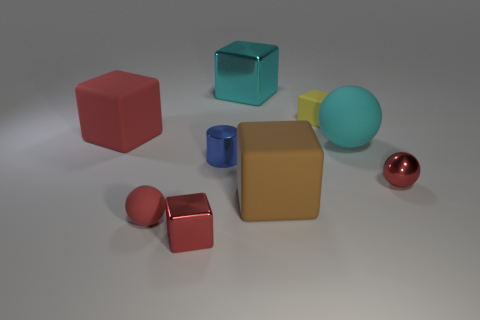Do the big block that is behind the big red object and the red ball to the left of the large brown rubber block have the same material?
Your answer should be compact. No. There is a large ball that is the same material as the large brown object; what color is it?
Give a very brief answer. Cyan. Does the tiny shiny cube have the same color as the tiny matte ball?
Make the answer very short. Yes. There is a metal thing that is the same size as the red rubber cube; what is its shape?
Offer a very short reply. Cube. What size is the blue shiny thing?
Offer a terse response. Small. Does the shiny cube that is behind the red matte ball have the same size as the rubber thing that is to the right of the tiny yellow block?
Give a very brief answer. Yes. There is a small block that is in front of the tiny cylinder that is behind the brown rubber block; what is its color?
Your response must be concise. Red. What material is the blue object that is the same size as the red metal sphere?
Ensure brevity in your answer.  Metal. How many metal objects are either small cylinders or small brown cubes?
Offer a terse response. 1. There is a object that is both on the left side of the tiny red metallic block and in front of the brown block; what is its color?
Give a very brief answer. Red. 